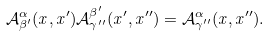Convert formula to latex. <formula><loc_0><loc_0><loc_500><loc_500>\mathcal { A } _ { \beta ^ { \prime } } ^ { \alpha } ( x , x ^ { \prime } ) \mathcal { A } _ { \gamma ^ { \prime \prime } } ^ { \beta ^ { \prime } } ( x ^ { \prime } , x ^ { \prime \prime } ) = \mathcal { A } _ { \gamma ^ { \prime \prime } } ^ { \alpha } ( x , x ^ { \prime \prime } ) .</formula> 